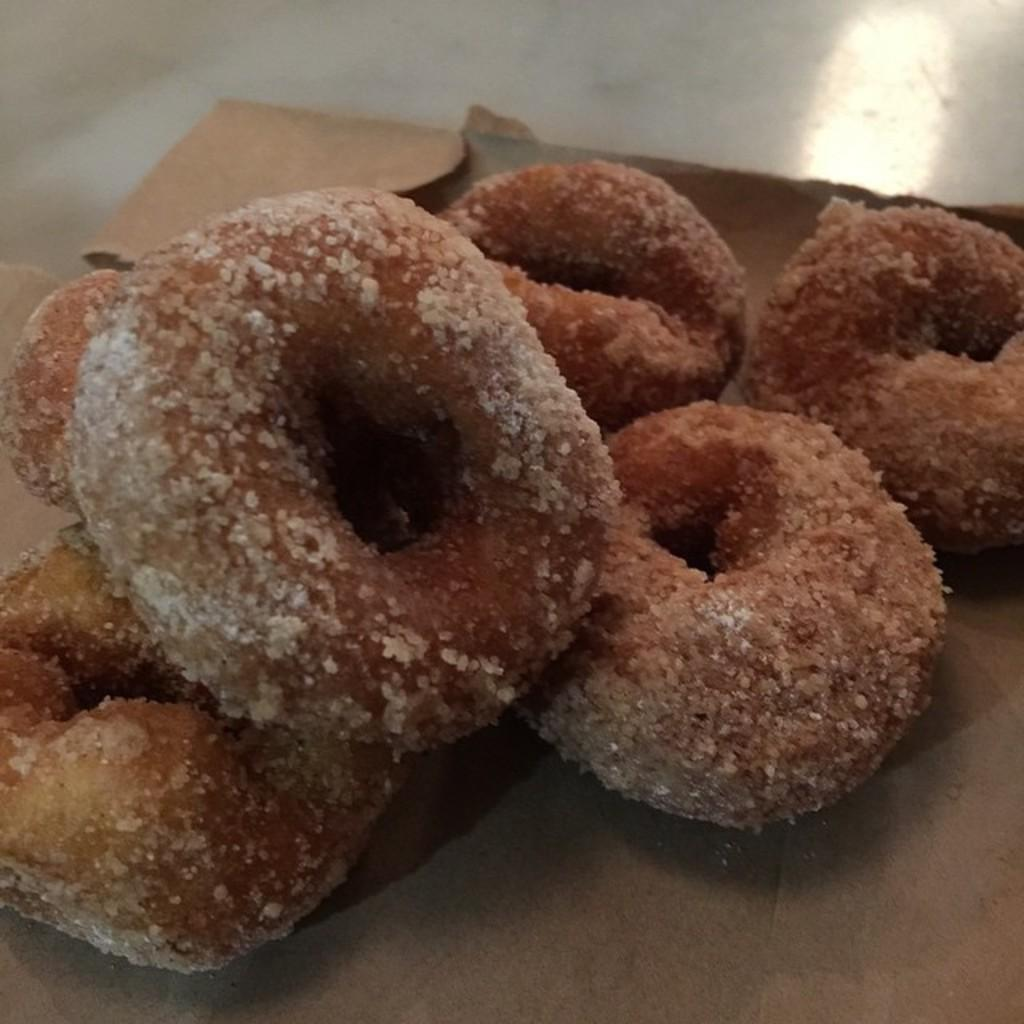What is placed on the box in the image? There is food placed on a box in the image. What material is the box made of? The box is made of cardboard. Where is the box located in the image? The box is placed on the floor. What color is the floor in the image? The floor is white in color. Can you tell me how many times the soap is used in the image? There is no soap present in the image, so it is not possible to determine how many times it is used. 